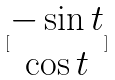<formula> <loc_0><loc_0><loc_500><loc_500>[ \begin{matrix} - \sin t \\ \cos t \end{matrix} ]</formula> 